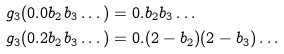<formula> <loc_0><loc_0><loc_500><loc_500>g _ { 3 } ( 0 . 0 b _ { 2 } b _ { 3 } \dots ) & = 0 . b _ { 2 } b _ { 3 } \dots \\ g _ { 3 } ( 0 . 2 b _ { 2 } b _ { 3 } \dots ) & = 0 . ( 2 - b _ { 2 } ) ( 2 - b _ { 3 } ) \dots</formula> 